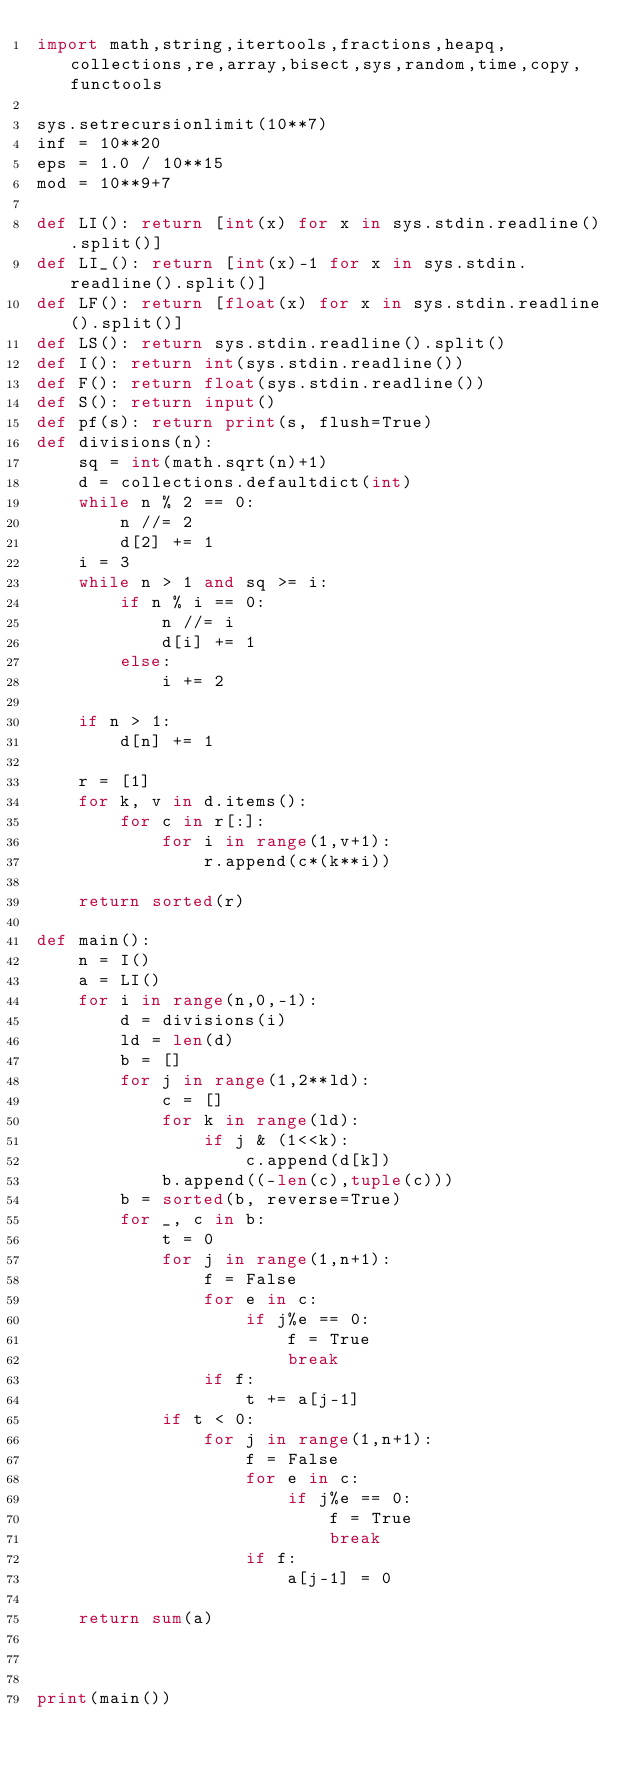<code> <loc_0><loc_0><loc_500><loc_500><_Python_>import math,string,itertools,fractions,heapq,collections,re,array,bisect,sys,random,time,copy,functools

sys.setrecursionlimit(10**7)
inf = 10**20
eps = 1.0 / 10**15
mod = 10**9+7

def LI(): return [int(x) for x in sys.stdin.readline().split()]
def LI_(): return [int(x)-1 for x in sys.stdin.readline().split()]
def LF(): return [float(x) for x in sys.stdin.readline().split()]
def LS(): return sys.stdin.readline().split()
def I(): return int(sys.stdin.readline())
def F(): return float(sys.stdin.readline())
def S(): return input()
def pf(s): return print(s, flush=True)
def divisions(n):
    sq = int(math.sqrt(n)+1)
    d = collections.defaultdict(int)
    while n % 2 == 0:
        n //= 2
        d[2] += 1
    i = 3
    while n > 1 and sq >= i:
        if n % i == 0:
            n //= i
            d[i] += 1
        else:
            i += 2

    if n > 1:
        d[n] += 1

    r = [1]
    for k, v in d.items():
        for c in r[:]:
            for i in range(1,v+1):
                r.append(c*(k**i))

    return sorted(r)

def main():
    n = I()
    a = LI()
    for i in range(n,0,-1):
        d = divisions(i)
        ld = len(d)
        b = []
        for j in range(1,2**ld):
            c = []
            for k in range(ld):
                if j & (1<<k):
                    c.append(d[k])
            b.append((-len(c),tuple(c)))
        b = sorted(b, reverse=True)
        for _, c in b:
            t = 0
            for j in range(1,n+1):
                f = False
                for e in c:
                    if j%e == 0:
                        f = True
                        break
                if f:
                    t += a[j-1]
            if t < 0:
                for j in range(1,n+1):
                    f = False
                    for e in c:
                        if j%e == 0:
                            f = True
                            break
                    if f:
                        a[j-1] = 0

    return sum(a)



print(main())


</code> 